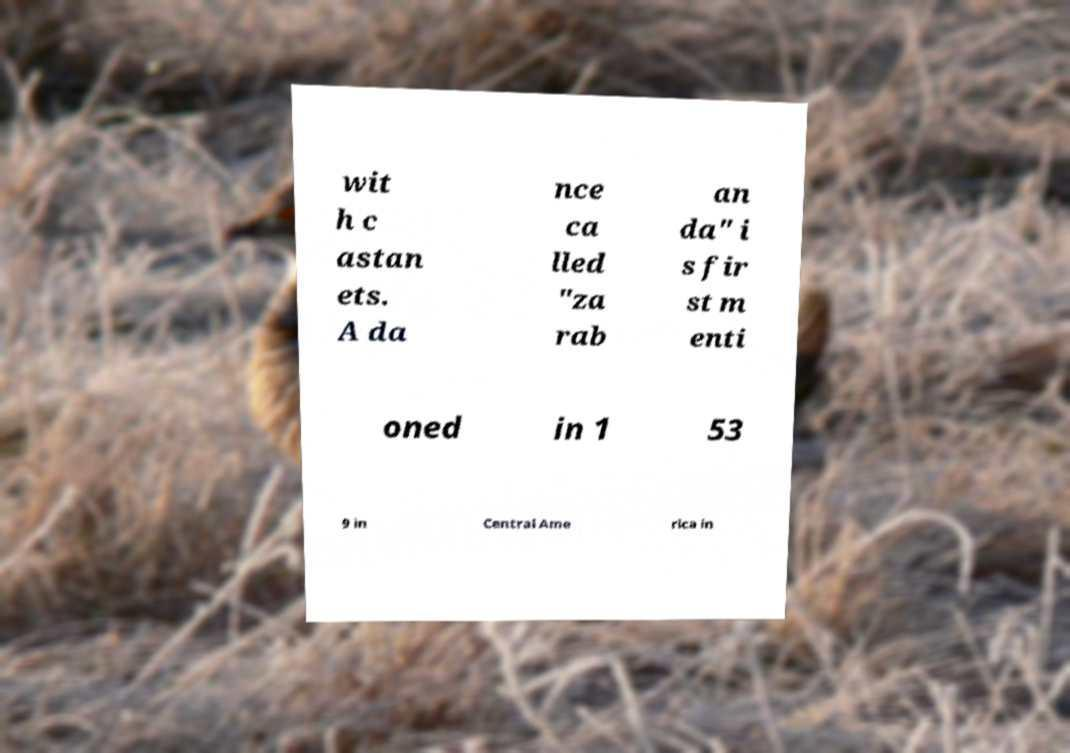Can you read and provide the text displayed in the image?This photo seems to have some interesting text. Can you extract and type it out for me? wit h c astan ets. A da nce ca lled "za rab an da" i s fir st m enti oned in 1 53 9 in Central Ame rica in 